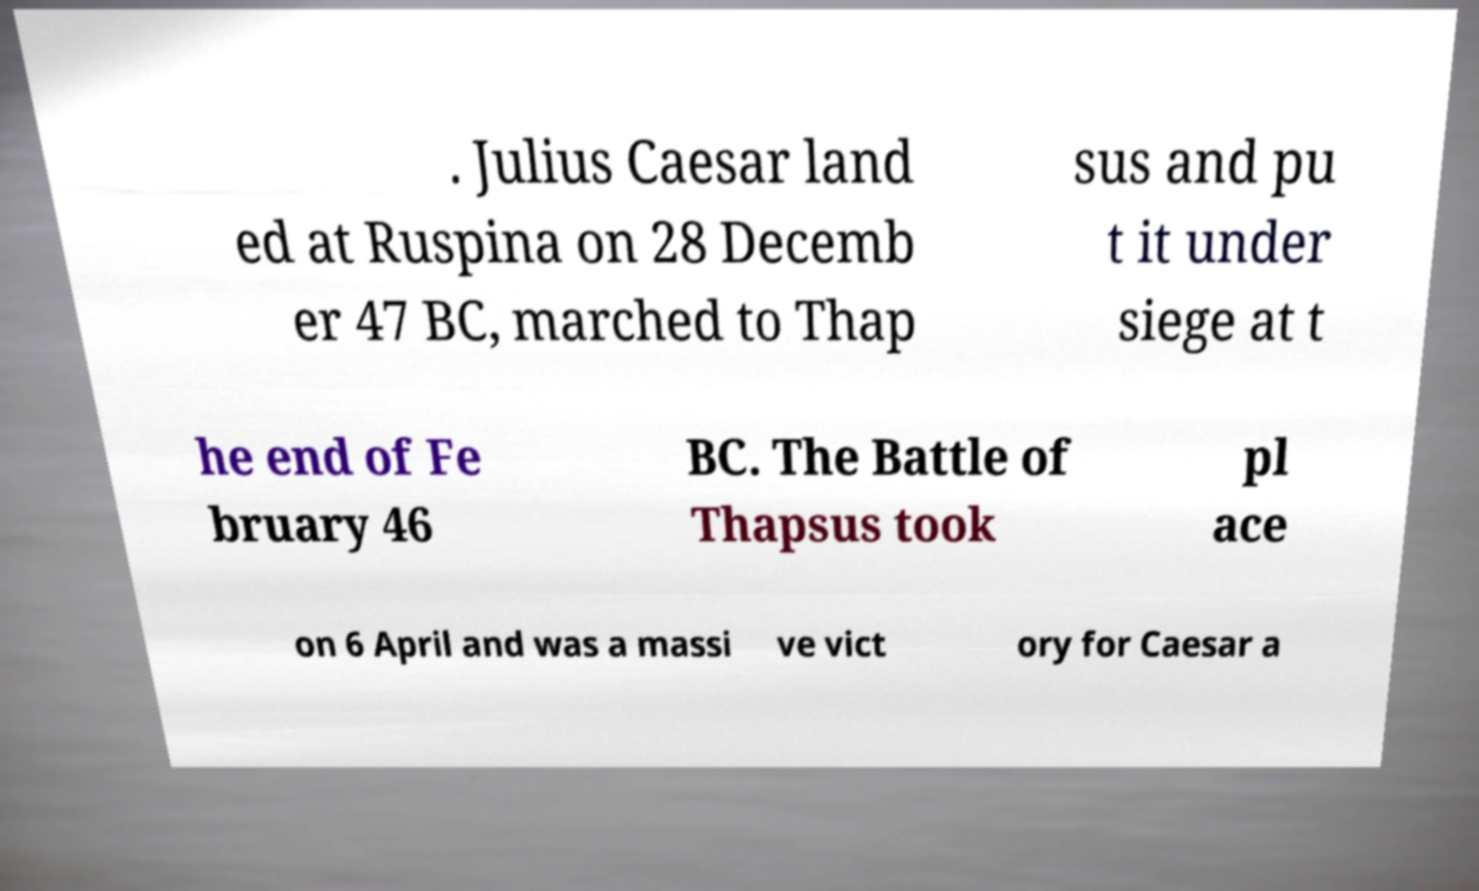For documentation purposes, I need the text within this image transcribed. Could you provide that? . Julius Caesar land ed at Ruspina on 28 Decemb er 47 BC, marched to Thap sus and pu t it under siege at t he end of Fe bruary 46 BC. The Battle of Thapsus took pl ace on 6 April and was a massi ve vict ory for Caesar a 